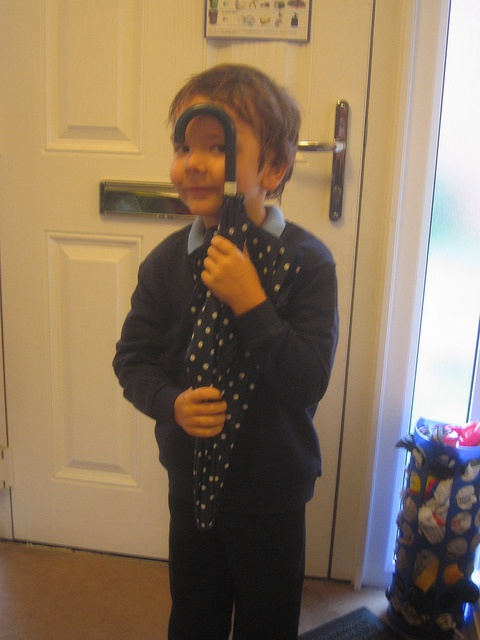Describe the objects in this image and their specific colors. I can see people in tan, black, brown, and maroon tones and umbrella in tan, black, maroon, and brown tones in this image. 